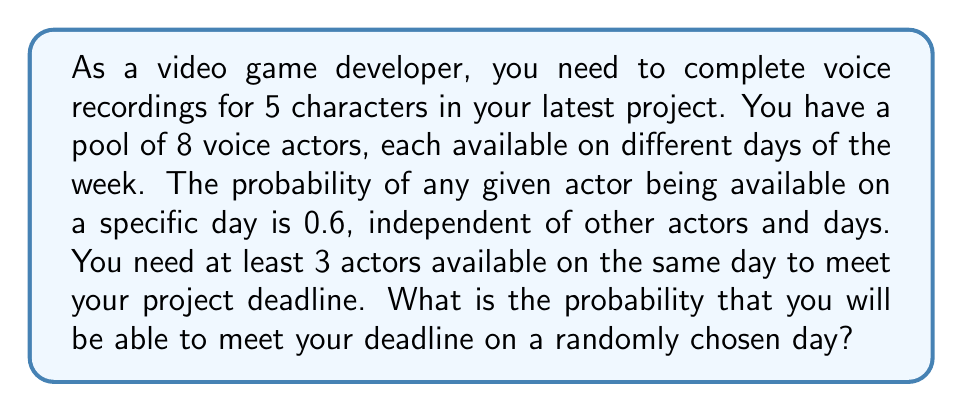Show me your answer to this math problem. To solve this problem, we can use the binomial probability distribution. Here's a step-by-step approach:

1) First, we need to calculate the probability of at least 3 actors being available on a given day.

2) Let X be the number of available actors on a given day. X follows a binomial distribution with n = 8 (total number of actors) and p = 0.6 (probability of an actor being available).

3) We want P(X ≥ 3), which is equivalent to 1 - P(X < 3) or 1 - [P(X = 0) + P(X = 1) + P(X = 2)].

4) The probability mass function for a binomial distribution is:

   $$P(X = k) = \binom{n}{k} p^k (1-p)^{n-k}$$

5) Let's calculate each probability:

   $$P(X = 0) = \binom{8}{0} 0.6^0 (1-0.6)^{8-0} = 1 \cdot 1 \cdot 0.4^8 \approx 0.00066$$
   
   $$P(X = 1) = \binom{8}{1} 0.6^1 (1-0.6)^{8-1} = 8 \cdot 0.6 \cdot 0.4^7 \approx 0.00394$$
   
   $$P(X = 2) = \binom{8}{2} 0.6^2 (1-0.6)^{8-2} = 28 \cdot 0.36 \cdot 0.4^6 \approx 0.01115$$

6) Now, we can calculate the probability of at least 3 actors being available:

   $$P(X \geq 3) = 1 - [P(X = 0) + P(X = 1) + P(X = 2)]$$
   $$= 1 - (0.00066 + 0.00394 + 0.01115)$$
   $$= 1 - 0.01575$$
   $$= 0.98425$$

7) Therefore, the probability of meeting the deadline on a randomly chosen day is approximately 0.98425 or 98.425%.
Answer: The probability of meeting the project deadline on a randomly chosen day is approximately 0.98425 or 98.425%. 